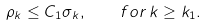<formula> <loc_0><loc_0><loc_500><loc_500>\rho _ { k } \leq C _ { 1 } \sigma _ { k } , \quad f o r \, k \geq k _ { 1 } .</formula> 